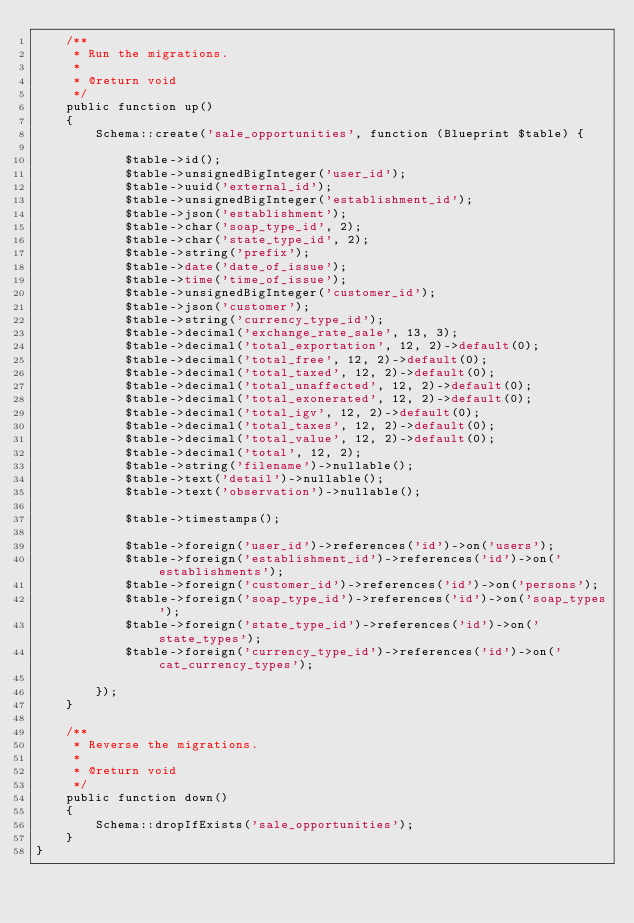<code> <loc_0><loc_0><loc_500><loc_500><_PHP_>    /**
     * Run the migrations.
     *
     * @return void
     */
    public function up()
    {
        Schema::create('sale_opportunities', function (Blueprint $table) {
           
            $table->id();
            $table->unsignedBigInteger('user_id');
            $table->uuid('external_id');
            $table->unsignedBigInteger('establishment_id');
            $table->json('establishment');
            $table->char('soap_type_id', 2);
            $table->char('state_type_id', 2);   
            $table->string('prefix'); 
            $table->date('date_of_issue');
            $table->time('time_of_issue');
            $table->unsignedBigInteger('customer_id');
            $table->json('customer');
            $table->string('currency_type_id');
            $table->decimal('exchange_rate_sale', 13, 3);
            $table->decimal('total_exportation', 12, 2)->default(0);
            $table->decimal('total_free', 12, 2)->default(0);
            $table->decimal('total_taxed', 12, 2)->default(0);
            $table->decimal('total_unaffected', 12, 2)->default(0);
            $table->decimal('total_exonerated', 12, 2)->default(0);
            $table->decimal('total_igv', 12, 2)->default(0);
            $table->decimal('total_taxes', 12, 2)->default(0);
            $table->decimal('total_value', 12, 2)->default(0);
            $table->decimal('total', 12, 2);
            $table->string('filename')->nullable(); 
            $table->text('detail')->nullable(); 
            $table->text('observation')->nullable(); 

            $table->timestamps();

            $table->foreign('user_id')->references('id')->on('users');
            $table->foreign('establishment_id')->references('id')->on('establishments');
            $table->foreign('customer_id')->references('id')->on('persons');
            $table->foreign('soap_type_id')->references('id')->on('soap_types');
            $table->foreign('state_type_id')->references('id')->on('state_types');  
            $table->foreign('currency_type_id')->references('id')->on('cat_currency_types');
            
        });
    }

    /**
     * Reverse the migrations.
     *
     * @return void
     */
    public function down()
    {
        Schema::dropIfExists('sale_opportunities');        
    }
}
</code> 